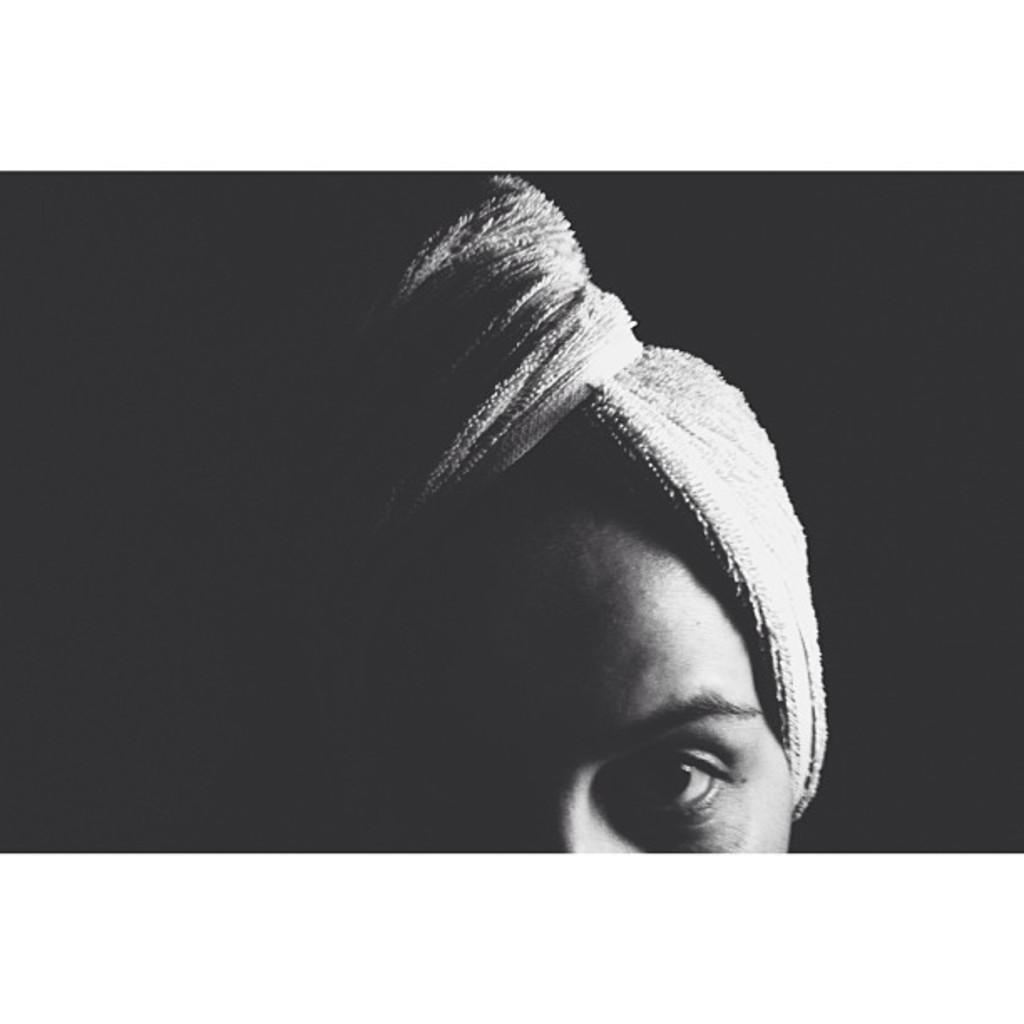What is the main subject of the image? There is a picture in the image. What can be seen in the picture? The picture contains a person. What is the color of the background in the picture? The background of the picture is black. Did the writer sign an agreement with the person in the image? There is no information about a writer or an agreement in the image, so we cannot answer this question. 